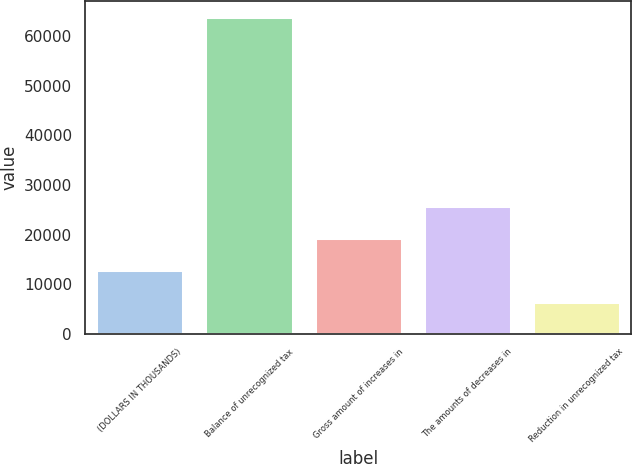Convert chart. <chart><loc_0><loc_0><loc_500><loc_500><bar_chart><fcel>(DOLLARS IN THOUSANDS)<fcel>Balance of unrecognized tax<fcel>Gross amount of increases in<fcel>The amounts of decreases in<fcel>Reduction in unrecognized tax<nl><fcel>12936.2<fcel>63928<fcel>19403.3<fcel>25870.4<fcel>6469.1<nl></chart> 